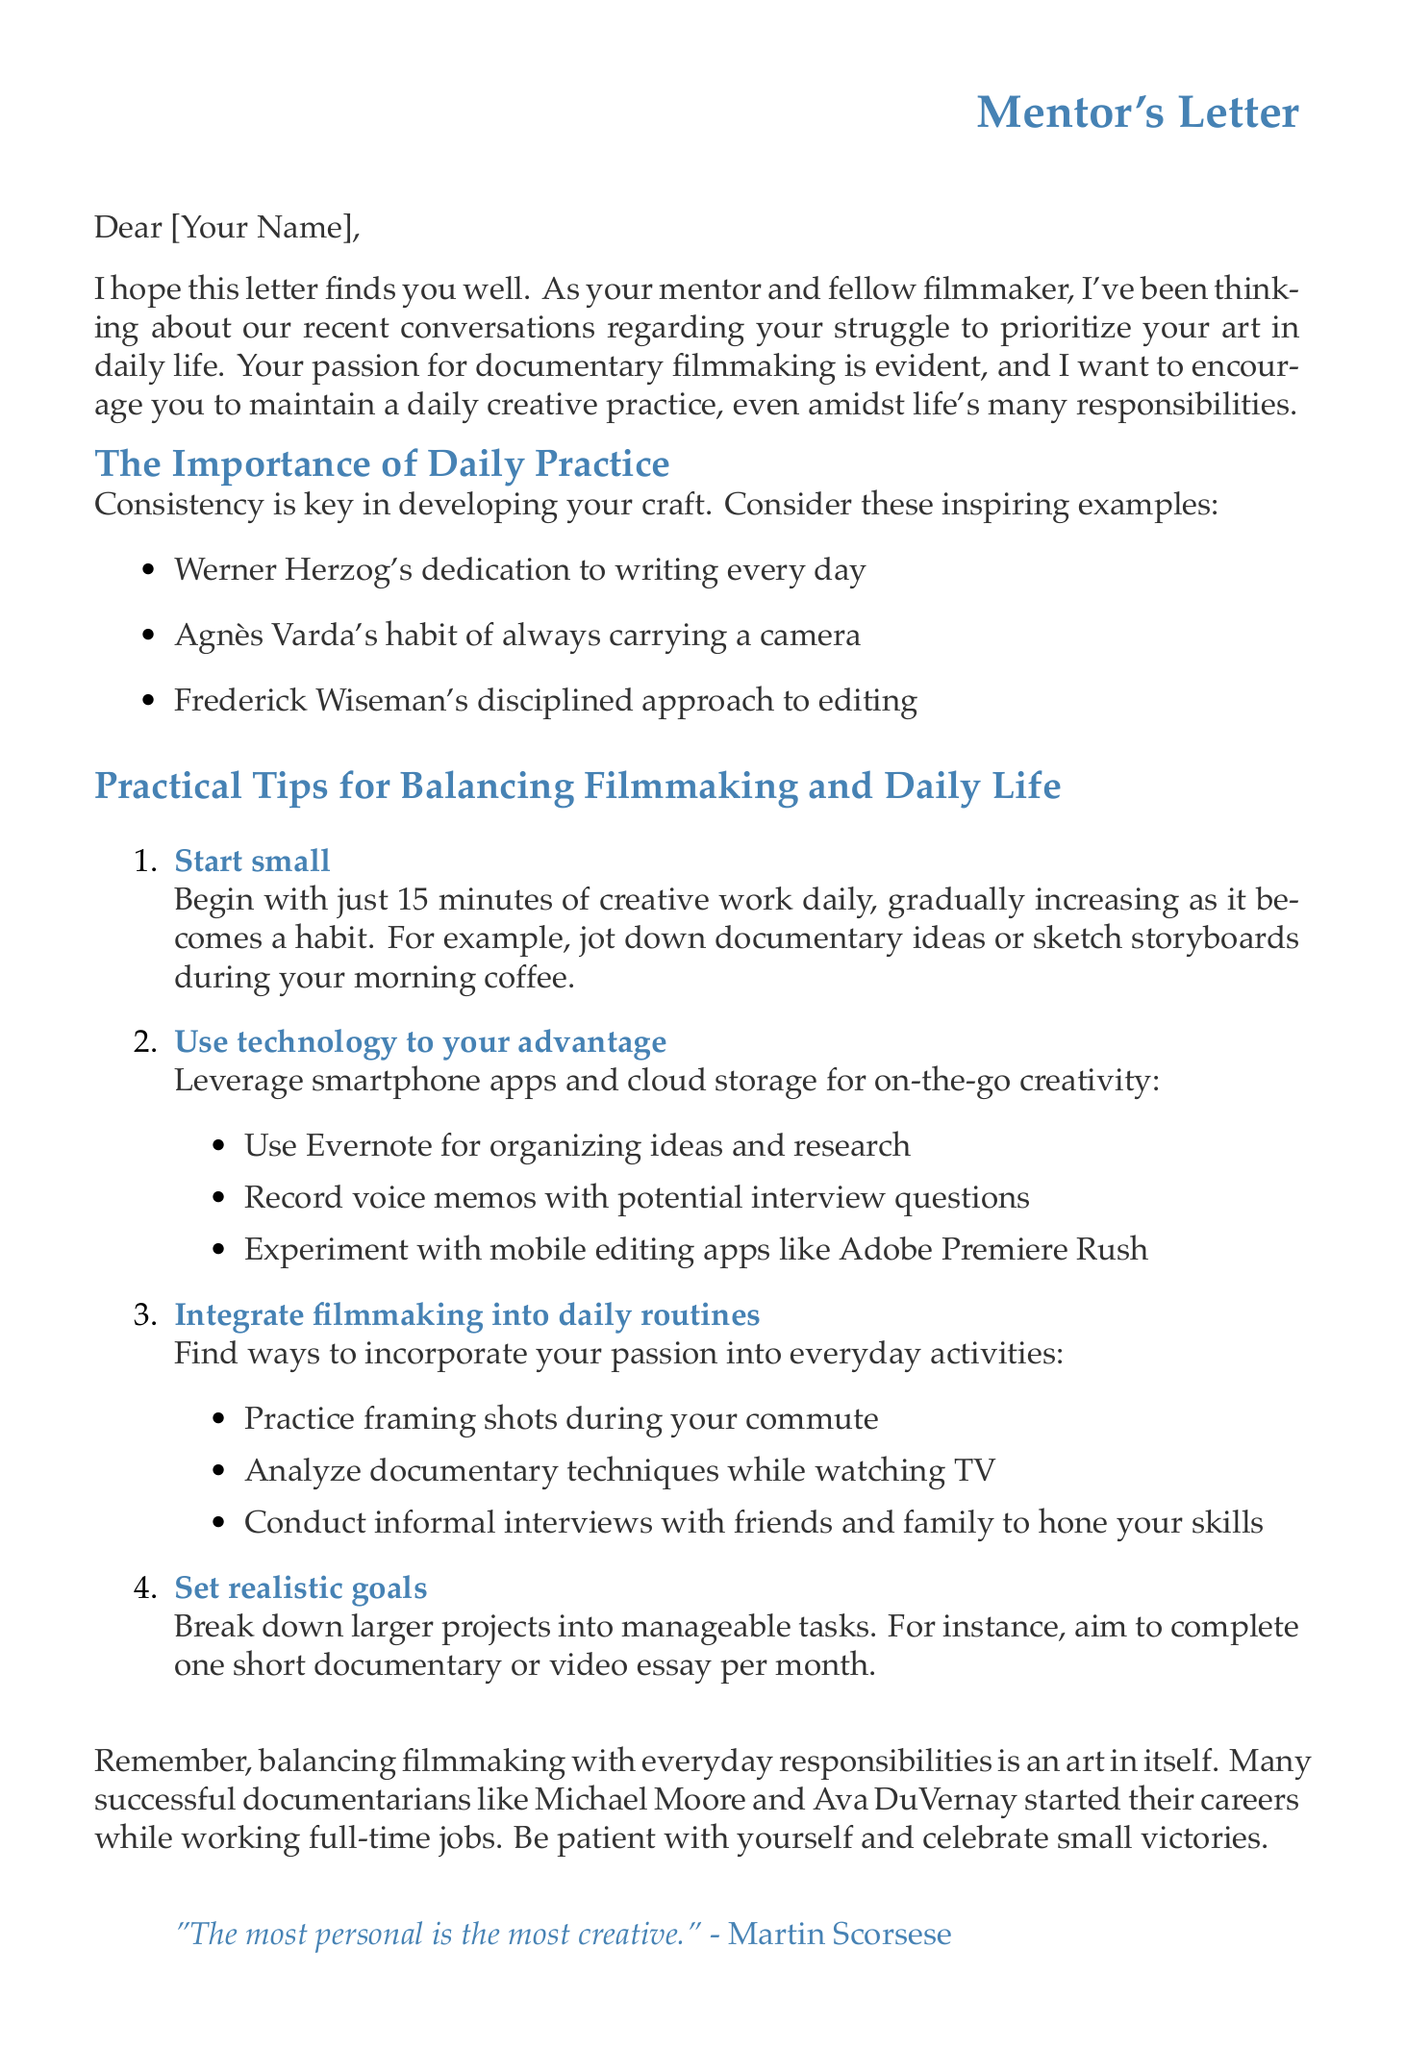what is the main point of the importance of daily practice? The main point outlines that consistency is key in developing one's craft.
Answer: Consistency is key in developing your craft who is the mentor mentioned in the letter? The document prompts to fill in the mentor's name, so a specific name isn't provided.
Answer: [Mentor's Name] which filmmaker is mentioned for carrying a camera always? This filmmaker is referenced as an example of dedication to their craft.
Answer: Agnès Varda what does the mentor suggest starting with in daily creative work? The letter advises beginning with a specific amount of time for practice.
Answer: 15 minutes what quote by Martin Scorsese is included in the letter? The quote emphasizes the personal aspect of creativity.
Answer: "The most personal is the most creative." how many short documentaries should one aim to complete per month? This is presented as a practical goal within the letter.
Answer: one short documentary what type of technology is suggested to use for creativity? The document recommends a specific kind of device to enhance creative practices.
Answer: smartphone apps what kind of tips are provided in the letter? The letter includes advice on integrating filmmaking into daily routines, among other suggestions.
Answer: practical tips 